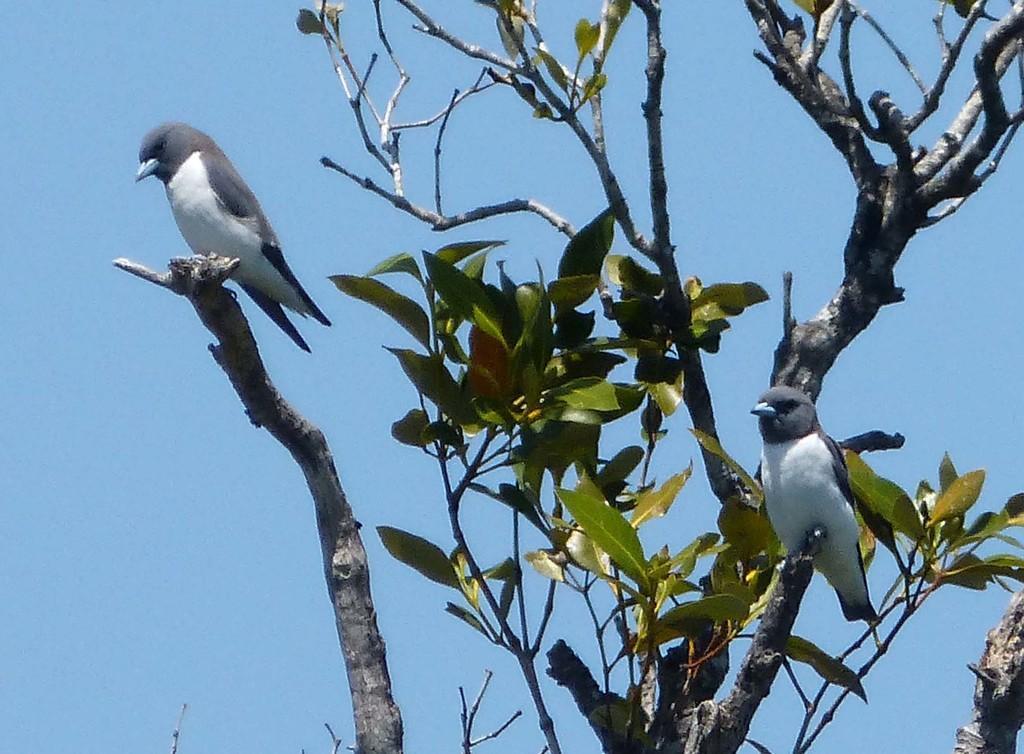Describe this image in one or two sentences. This image consists of birds. Which are standing on the branch of a tree, which is in the front. 